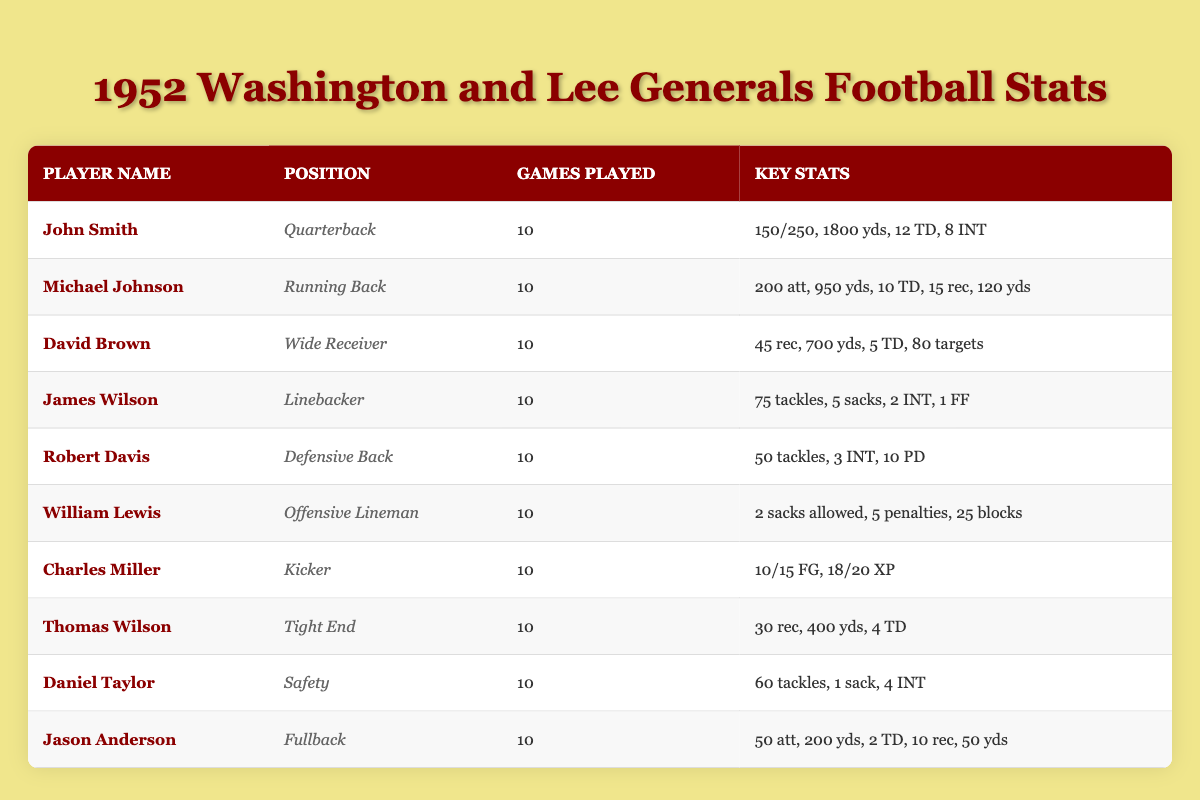What is the total number of touchdowns scored by Michael Johnson? Michael Johnson's entry shows he scored 10 touchdowns, so we simply read that value directly from his row.
Answer: 10 What is the total number of interceptions thrown by John Smith? John Smith's row displays that he had 8 interceptions. This value is directly found in the table without any calculations needed.
Answer: 8 How many passing yards did David Brown accumulate? The table provides David Brown's passing yards as 700, which is stated in his stats, requiring no further calculations.
Answer: 700 Which player had the most tackles? James Wilson had 75 tackles, and Daniel Taylor had 60. Comparing these two values shows that James Wilson had the highest total. This requires observing the tackle counts from both players.
Answer: James Wilson How many total field goals did Charles Miller make? The table indicates that Charles Miller made 10 field goals out of 15 attempts. This value is presented directly and doesn't require any calculation, so we refer to the "field goals made" data.
Answer: 10 What is the average number of touchdowns scored by the total offensive players listed (John Smith, Michael Johnson, David Brown, Thomas Wilson, Jason Anderson)? Adding the touchdowns: John Smith (12), Michael Johnson (10), David Brown (5), Thomas Wilson (4), Jason Anderson (2). Total = 12 + 10 + 5 + 4 + 2 = 33. Since there are 5 players, the average = 33/5 = 6.6. This requires calculating the total and dividing it by the count of players.
Answer: 6.6 Did any player score more than 10 touchdowns? The player with the most touchdowns, Michael Johnson, scored 10. No player exceeded that. A simple observation of the touchdown stats confirms that no player has a value greater than 10.
Answer: No Which position had the highest number of receptions? David Brown as a Wide Receiver had 45 receptions, which is the highest among all players listed. Comparing Brown's receptions against others requires checking the reception numbers of players in the table.
Answer: Wide Receiver (David Brown) How many total rushing yards did all running backs combined achieve? Michael Johnson had 950 rushing yards and Jason Anderson had 200 rushing yards. Combining these gives a total: 950 + 200 = 1150. Therefore, we sum the rushing yards of the two running backs to obtain the total.
Answer: 1150 